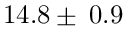Convert formula to latex. <formula><loc_0><loc_0><loc_500><loc_500>1 4 . 8 \pm \, 0 . 9</formula> 